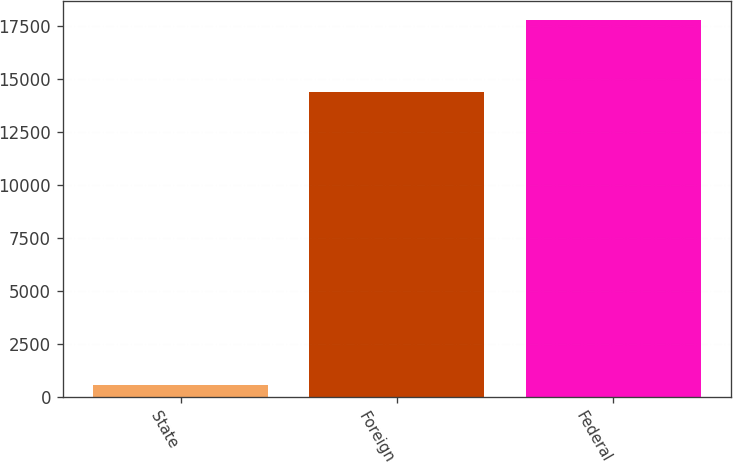<chart> <loc_0><loc_0><loc_500><loc_500><bar_chart><fcel>State<fcel>Foreign<fcel>Federal<nl><fcel>564<fcel>14356<fcel>17771<nl></chart> 